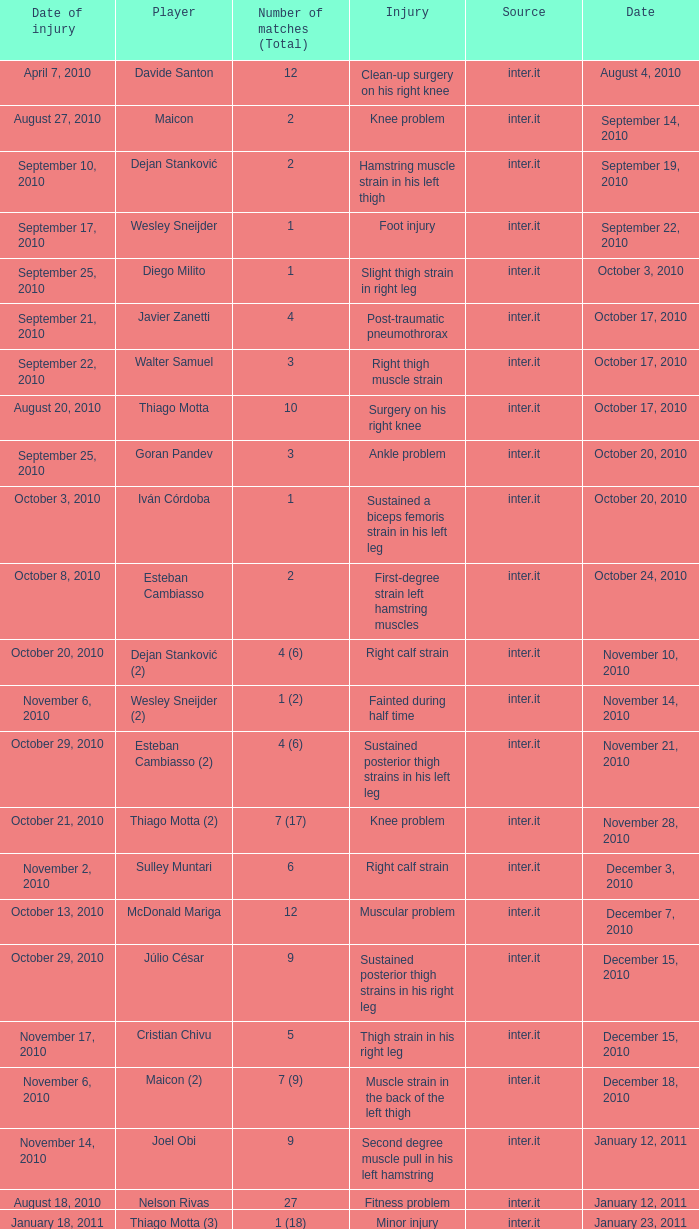What is the date of injury for player Wesley sneijder (2)? November 6, 2010. 